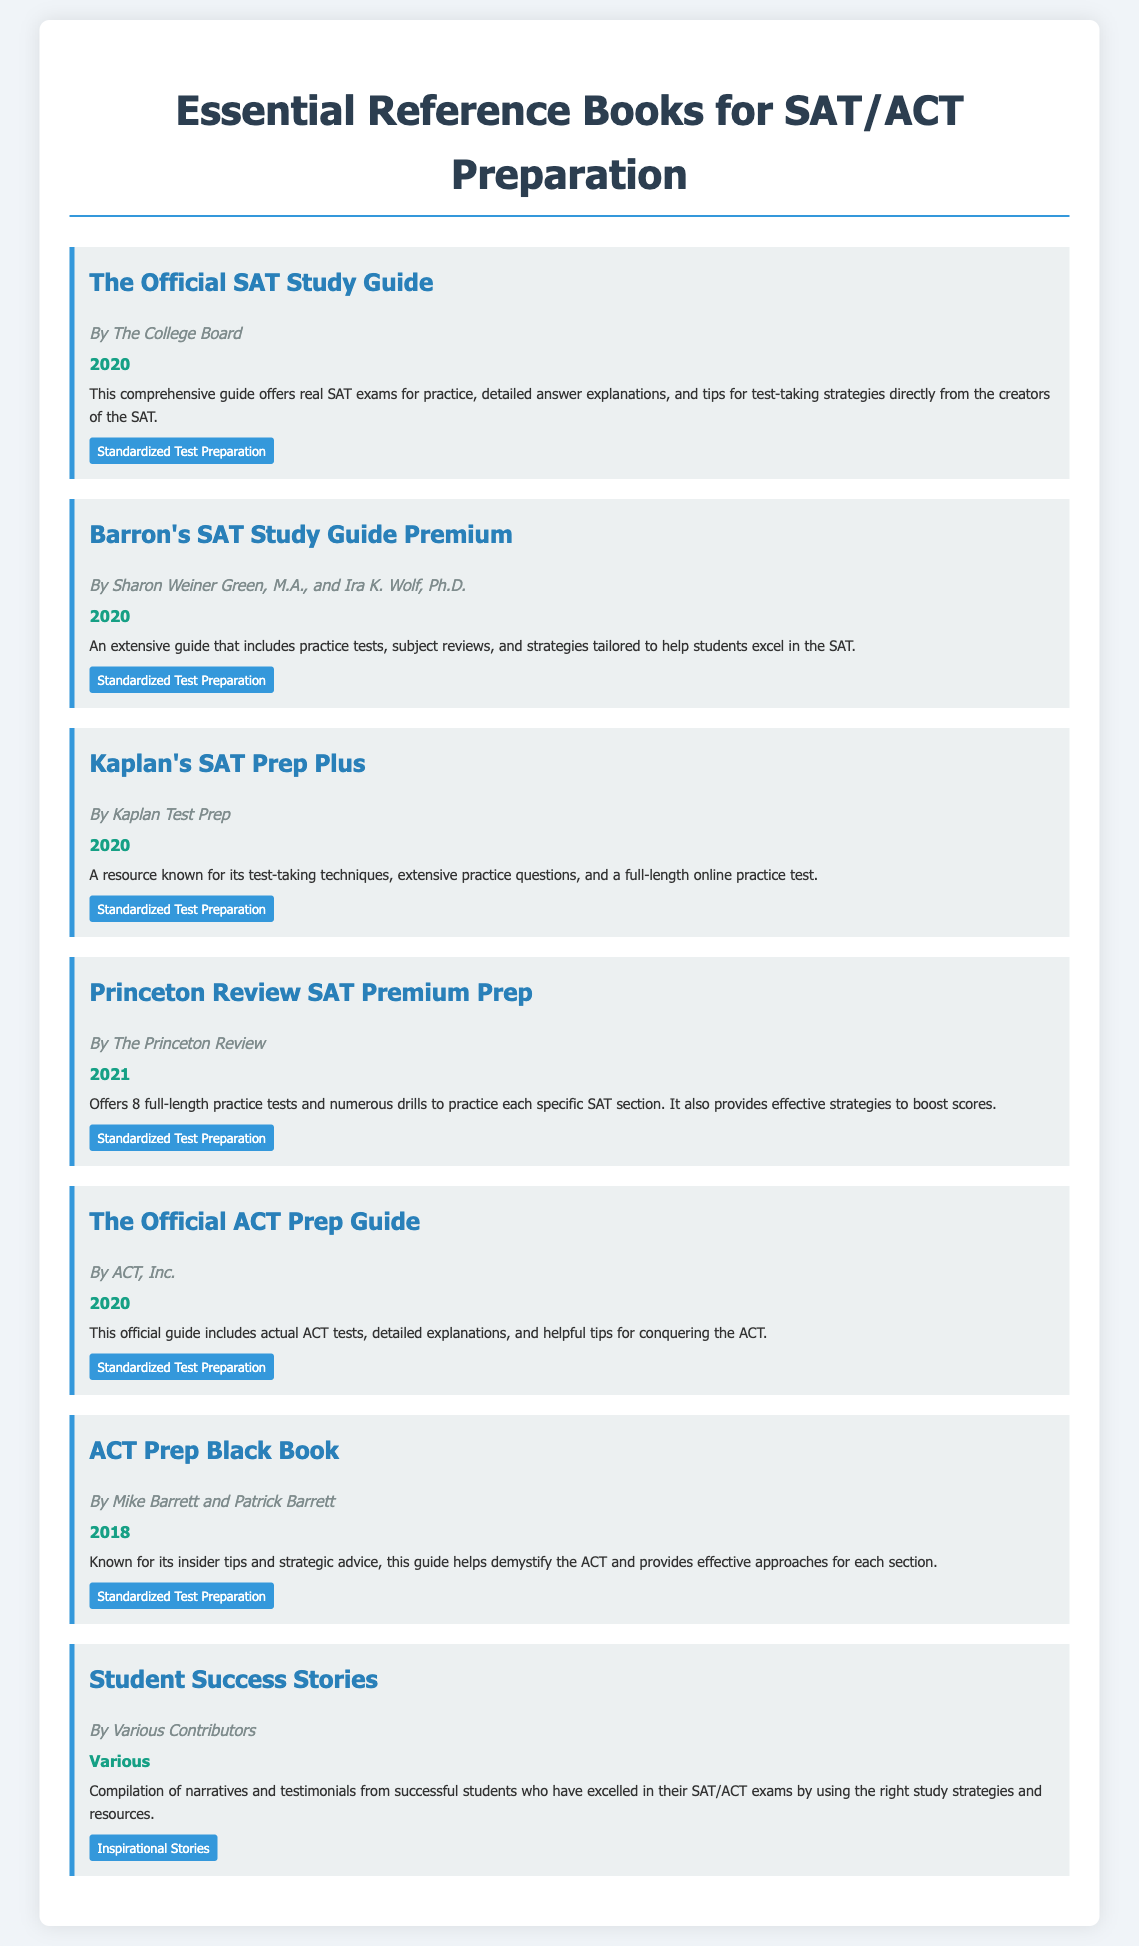What is the title of the first book? The title is explicitly listed in the document as the first book entry.
Answer: The Official SAT Study Guide Who is the author of "Kaplan's SAT Prep Plus"? The author's name is clearly mentioned in the corresponding book section.
Answer: Kaplan Test Prep What year was "ACT Prep Black Book" published? The publication year is noted under the respective book details.
Answer: 2018 How many practice tests are offered in "Princeton Review SAT Premium Prep"? The document specifies that this book includes a certain number of practice tests in its description.
Answer: 8 What type of content is featured in "Student Success Stories"? The document describes the type of content included in this book entry, highlighting its nature.
Answer: Inspirational Stories Which book is authored by The College Board? The document lists the authors for each book, allowing easy identification of the one by The College Board.
Answer: The Official SAT Study Guide Which book was published most recently? The years of publication for each book are provided, allowing comparison to determine the most recent one.
Answer: Princeton Review SAT Premium Prep 